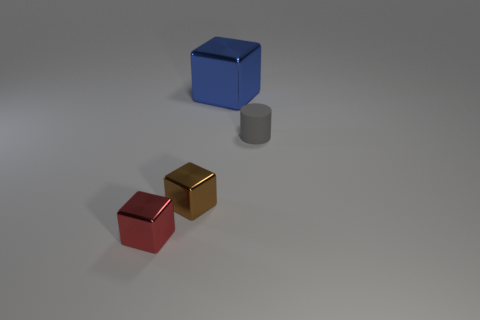What materials do the objects in this image seem to be made of? The objects in the image appear to be 3D renderings with materials that mimic matte and shiny surfaces. The red and gold cubes have a reflective surface suggesting a metallic texture, whereas the blue cube and gray cylinder exhibit a matte finish, implying a less reflective material like plastic or painted metal. 